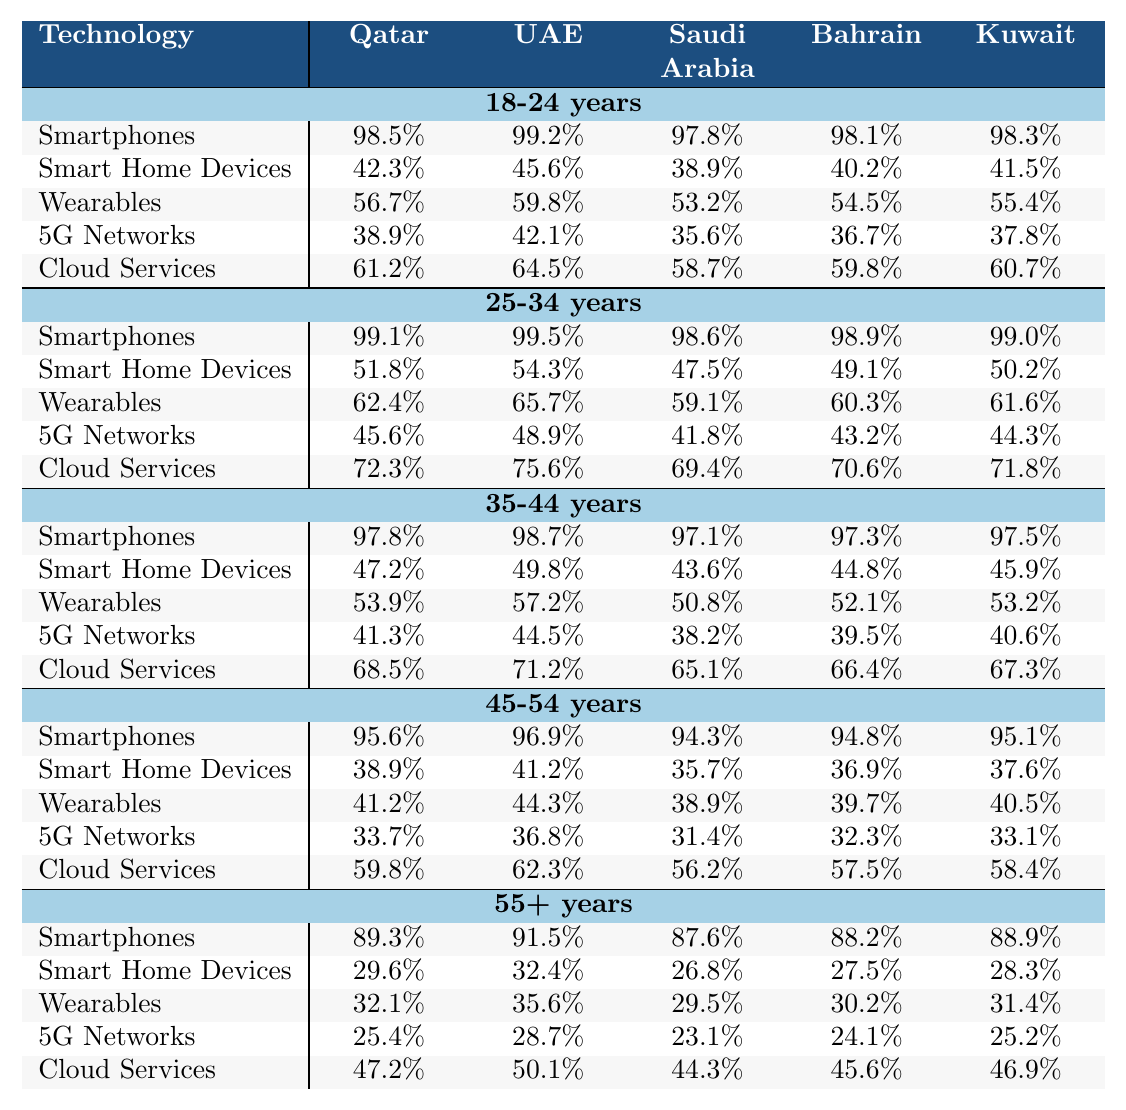What is the adoption rate of smartphones among the 25-34 years demographic in Qatar? The table shows that for the 25-34 years demographic, Qatar has a smartphone adoption rate of 99.1%.
Answer: 99.1% Which country has the highest adoption rate for cloud services among the 35-44 years age group? By checking the cloud services adoption rates in the table, the United Arab Emirates has the highest adoption rate for the 35-44 years demographic at 71.2%.
Answer: United Arab Emirates What is the difference in smartphone adoption rates between the 18-24 years and 55+ years demographics in Bahrain? The smartphone adoption rate for the 18-24 years demographic in Bahrain is 98.1%, and for the 55+ years, it is 88.2%. The difference is 98.1% - 88.2% = 9.9%.
Answer: 9.9% In which demographic does Kuwait have the highest adoption rate for wearables? The table indicates that for Kuwait, the 25-34 years demographic has the highest wearables adoption rate at 61.6%.
Answer: 25-34 years Is the adoption rate of smart home devices higher in Qatar or Saudi Arabia for the 45-54 years demographic? In the table, Qatar has a smart home device adoption rate of 38.9%, while Saudi Arabia has 35.7%. Therefore, Qatar's rate is higher than Saudi Arabia’s.
Answer: Yes What is the average adoption rate for 5G networks among all demographics in the UAE? The 5G network adoption rates for the UAE are 42.1%, 48.9%, 44.5%, 36.8%, and 28.7%. To find the average, sum the rates: (42.1 + 48.9 + 44.5 + 36.8 + 28.7) = 200. The average is 200/5 = 40.0%.
Answer: 40.0% For the 55+ years demographic, which country shows the lowest adoption rate for smart home devices? The smart home device adoption rates for the 55+ years demographic are Qatar (29.6%), UAE (32.4%), Saudi Arabia (26.8%), Bahrain (27.5%), and Kuwait (28.3%). Saudi Arabia has the lowest at 26.8%.
Answer: Saudi Arabia Which technology has the highest adoption rate for the 18-24 years demographic in Bahrain? The table shows that for the 18-24 years demographic in Bahrain, the smartphone adoption rate is 98.1%, which is higher than the other technologies listed for that demographic.
Answer: Smartphones What is the overall trend in smartphone adoption rates from the 18-24 years to the 55+ years demographic in Qatar? Looking at the table, the smartphone adoption rates in Qatar decrease as the age demographic increases, starting from 98.5% in the 18-24 years group to 89.3% in the 55+ years group.
Answer: Decreasing trend Which country has a higher wearables adoption rate for the 45-54 years demographic, Saudi Arabia or Kuwait? In the table, Saudi Arabia's wearables adoption rate is 38.9%, while Kuwait’s is 40.5%. Therefore, Kuwait has a higher rate.
Answer: Kuwait 